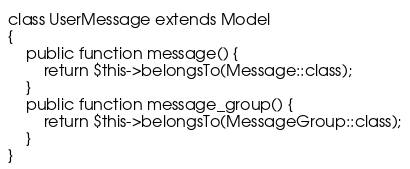Convert code to text. <code><loc_0><loc_0><loc_500><loc_500><_PHP_>class UserMessage extends Model
{
    public function message() {
        return $this->belongsTo(Message::class);
    }
    public function message_group() {
        return $this->belongsTo(MessageGroup::class);
    }
}
</code> 